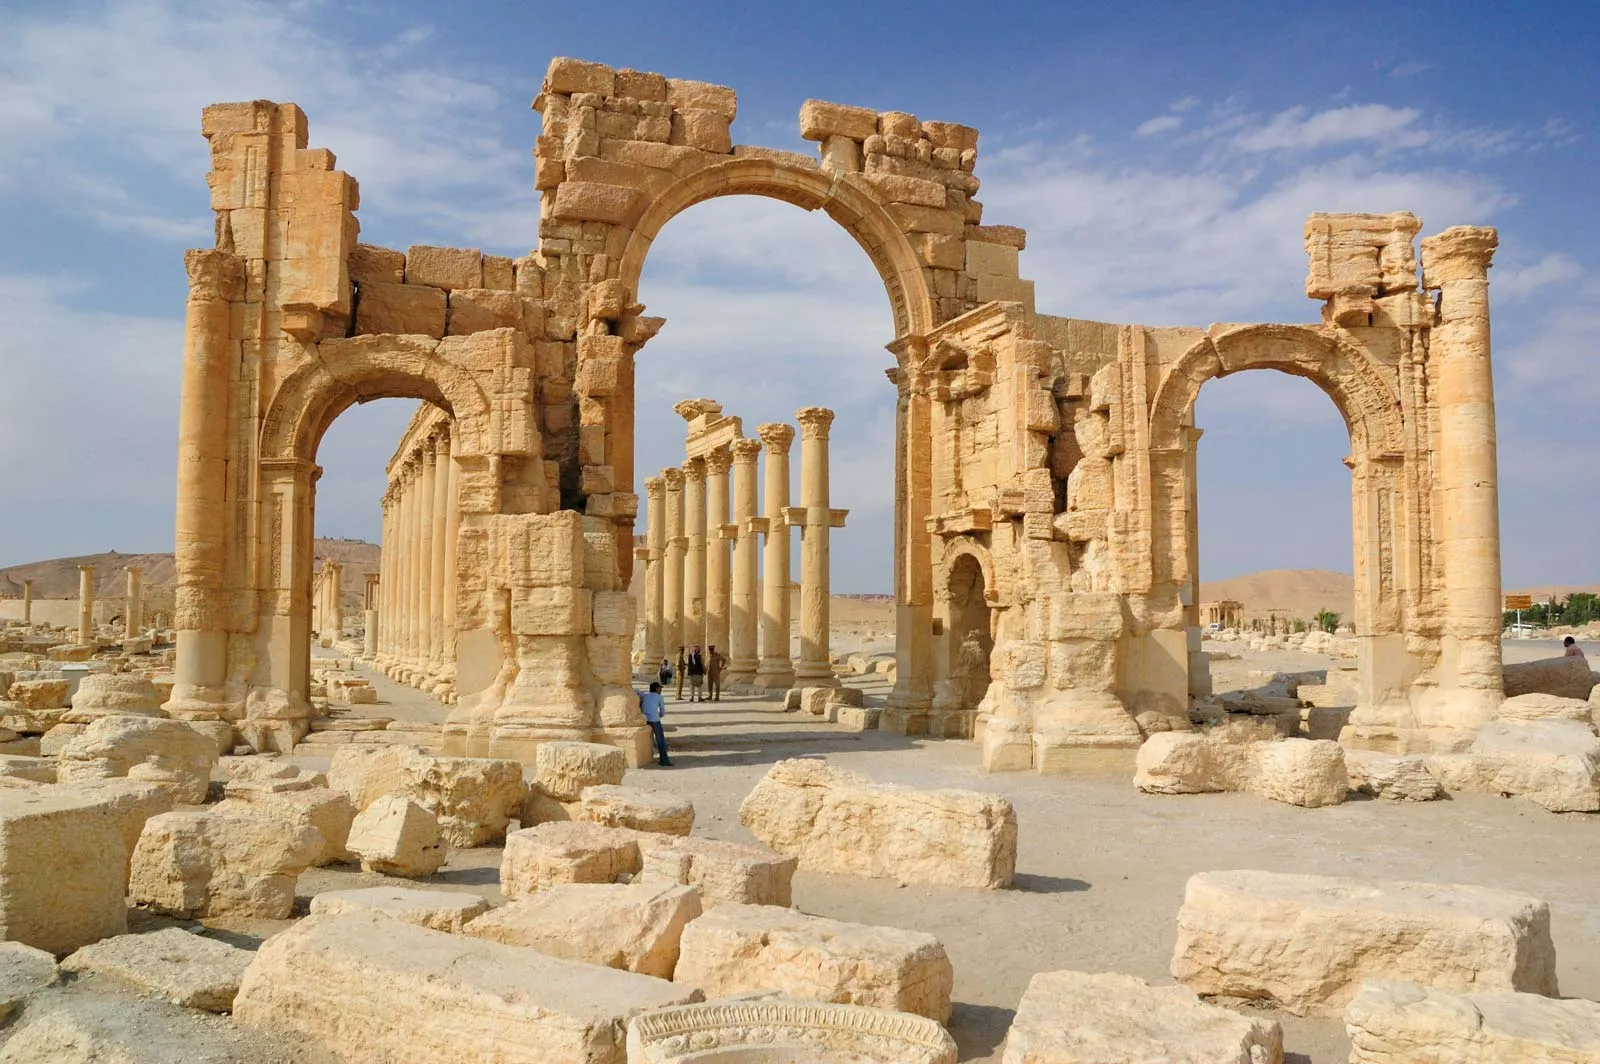What would it have been like to walk through Palmyra during its peak? Walking through Palmyra during its peak would have been a vibrant and bustling experience. The city was a melting pot of cultures, being a significant trade hub between the Roman Empire and Eastern civilizations. The streets would be lined with towering columns and grand arches, guiding you through a labyrinth of markets filled with goods from across the known world – spices, silks, precious stones, and exotic animals. The air would be filled with the sounds of merchants haggling, children playing, and travelers sharing tales of distant lands. The architecture around you, a blend of Greco-Roman and local styles, would demonstrate the city's prosperity and its role as a cultural crossroads. Temples and public baths would be frequented by citizens and visitors alike, exemplifying the city's sophisticated lifestyle and devotion to both communal and spiritual life. The vibrancy and richness of Palmyra at its zenith would leave a lasting impression on any visitor. Imagine a fictional discovery under the ruins of Palmyra. Underneath the ruins of Palmyra, archaeologists stumble upon an extraordinary discovery – a hidden subterranean city, perfectly preserved from antiquity. This underground metropolis, connected through secret passageways and tunnels, contains ornate chambers adorned with untouched frescoes, depicting scenes of daily life, mythology, and legendary figures from the city's storied past. Among the treasures, they find lost manuscripts and scrolls that hold the key to forgotten knowledge and technologies, revealing secrets about ancient medicine, astronomy, and even undiscovered philosophies. These scripts hint at Palmyra’s role not just as a trade hub but also as a center of learning and innovation, possibly holding the blueprint to an ancient machine, unlike anything seen before. The discovery ignites a global intrigue, as historians and scientists converge to unravel the mysteries locked within this hidden world, reshaping our understanding of ancient civilizations and their incredible achievements.  What might a day in the life of a merchant in Palmyra have been like? A merchant in Palmyra would start his day before dawn, preparing his goods for the day's trading in the bustling marketplace. He would load his cart with exotic items from distant lands – spices from India, silks from China, and locally crafted jewelry – ensuring to display them attractively to entice customers. As the sun rises, the city comes alive with activity. The merchant would engage in lively bargaining with traders and locals, showcasing his knowledge of different languages and customs to secure the best deals.

During the hottest part of the day, he might retreat to a shaded colonnade or a public bath to rest and socialize, sharing news and gossip from the various trade routes. By evening, as the market winds down, he would tally his earnings, often in various currencies, and prepare for the next day. After the market, he might attend a local gathering place or a temple to offer thanks for a profitable day. The merchant's life, though busy and sometimes fraught with challenges, would be filled with vibrant interactions and the constant excitement of new opportunities and discoveries.  Imagine a mystical event that could happen around the ruins of Palmyra. As night falls over the ruins of Palmyra, the moonlight casts a magical glow across the sandstone structures, illuminating the ancient carvings. Suddenly, a soft, ethereal music fills the air, seemingly coming from nowhere and everywhere at once. The ground beneath the ruins begins to shimmer, revealing a hidden pathway that glows with an otherworldly light. From this path emerges a procession of ghostly figures clad in ancient Palmyrene attire, re-enacting a long-forgotten ritual. As they dance and chant, the figures animate the carvings and frescoes, bringing the city back to life in its prime, if only for a moment.

Witnessing this mystical event, a group of archaeologists and tourists are astounded as they see history unfolding before their eyes, offering them an unparalleled insight into the daily lives, ceremonies, and celebrations of ancient Palmyra. As the night progresses, the figures slowly fade away, leaving behind a sense of awe and wonder. The pathway disappears, but the experience leaves an indelible mark on those who witnessed it, convinced that they have glimpsed the soul of this magnificent city. 